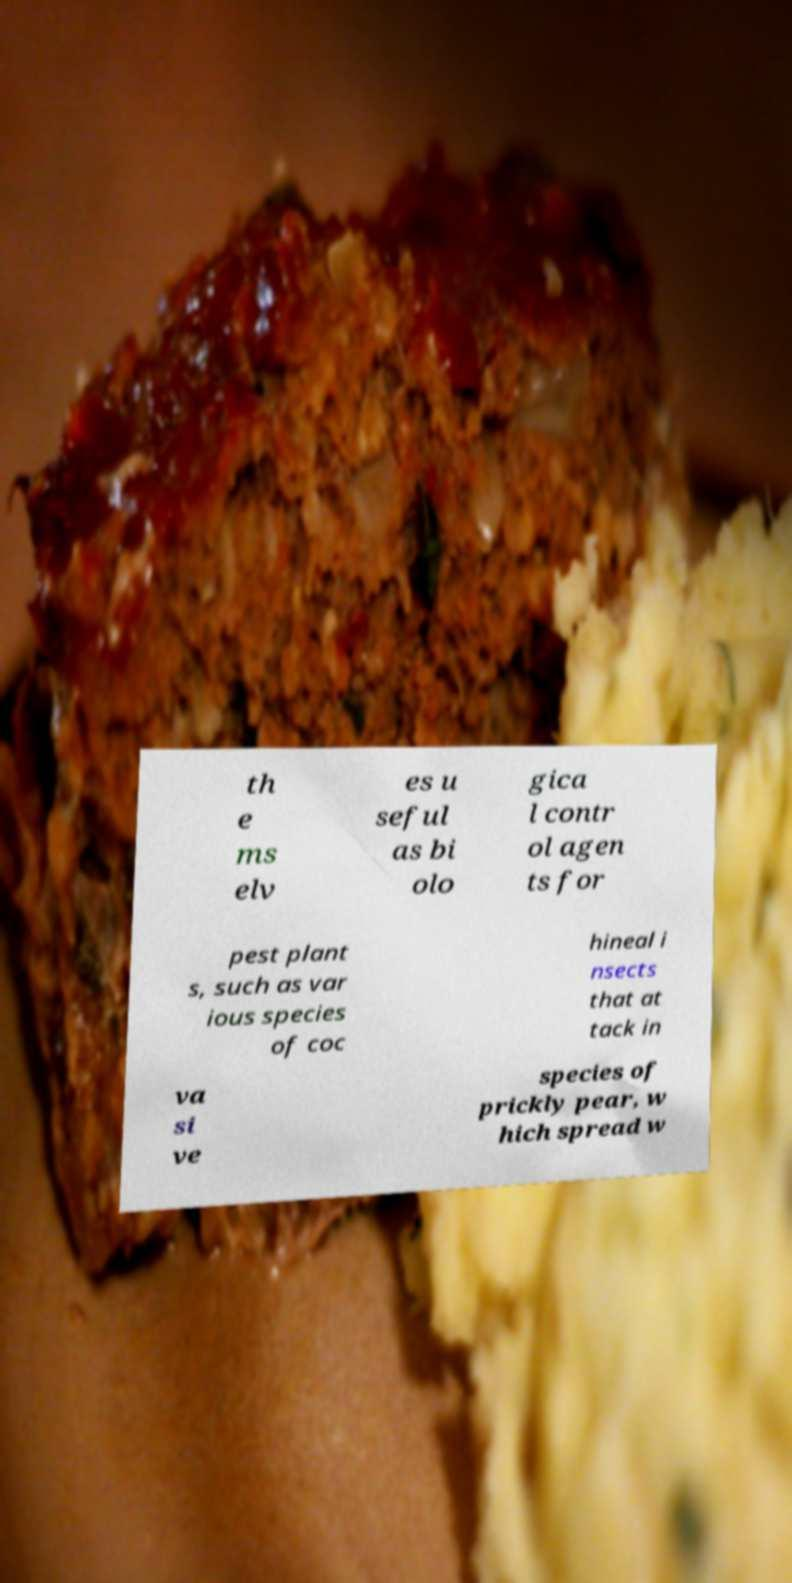Please identify and transcribe the text found in this image. th e ms elv es u seful as bi olo gica l contr ol agen ts for pest plant s, such as var ious species of coc hineal i nsects that at tack in va si ve species of prickly pear, w hich spread w 